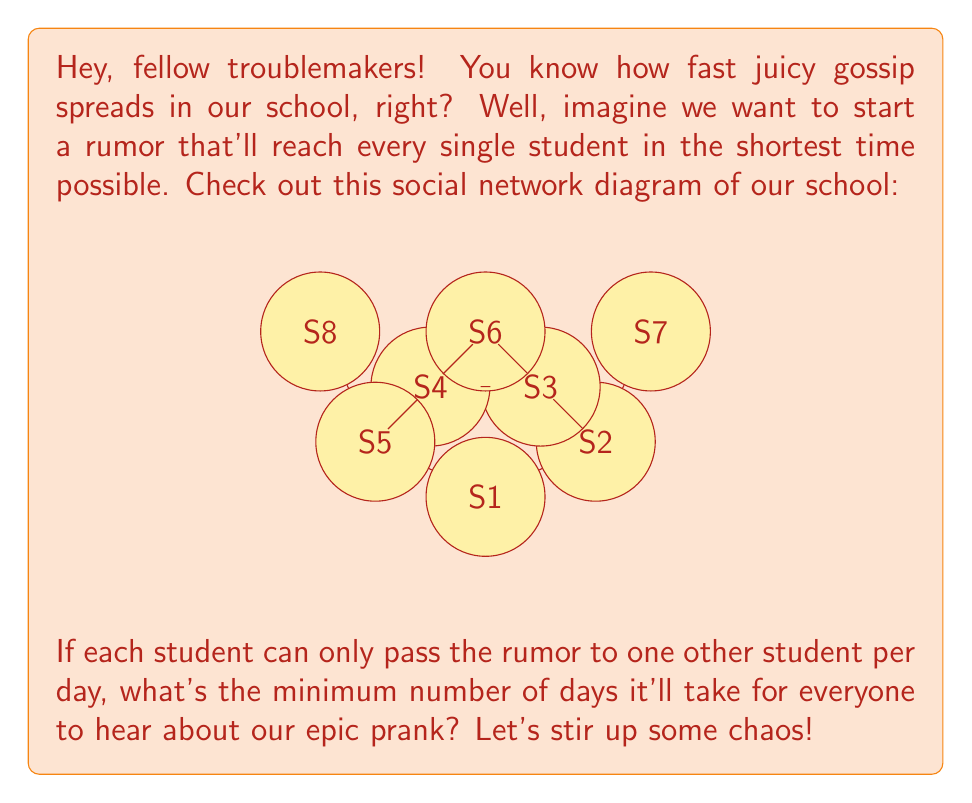Can you answer this question? Alright, fellow mischief-makers, let's break this down:

1) First, we need to recognize that this problem is about finding the minimum spanning tree of our social network graph. The minimum spanning tree will give us the least number of connections needed to reach all students.

2) We can solve this using Kruskal's algorithm or Prim's algorithm. Let's use Kruskal's algorithm because it's simpler and we're lazy pranksters:

   - Start with 8 isolated vertices (students)
   - Add the shortest edge that doesn't create a cycle
   - Repeat until we have 7 edges (for 8 vertices, we need 7 edges to connect them all)

3) In our case, all edges have the same weight (1 day), so we can add them in any order as long as we don't create cycles.

4) Let's count the edges we need:
   $$\text{Edge 1: S1 - S2}$$
   $$\text{Edge 2: S2 - S3}$$
   $$\text{Edge 3: S3 - S4}$$
   $$\text{Edge 4: S4 - S5}$$
   $$\text{Edge 5: S3 - S6}$$
   $$\text{Edge 6: S2 - S7}$$
   $$\text{Edge 7: S5 - S8}$$

5) The number of edges in our minimum spanning tree is 7, which means it will take 7 days for the rumor to spread to all students if each student can only tell one other student per day.

So, in 7 days, our epic prank rumor will have the whole school buzzing!
Answer: 7 days 